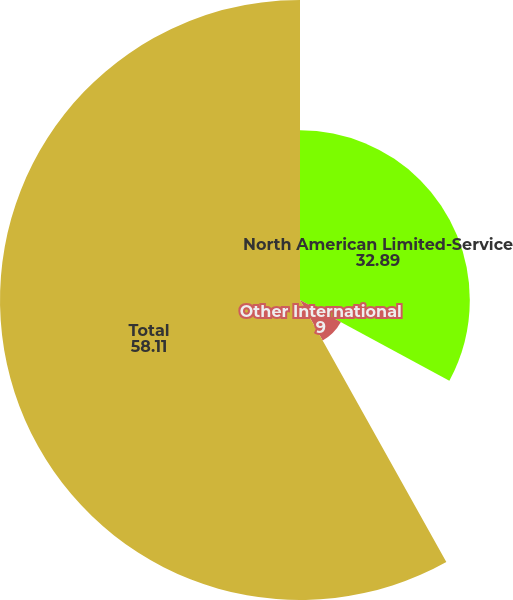<chart> <loc_0><loc_0><loc_500><loc_500><pie_chart><fcel>North American Limited-Service<fcel>Other International<fcel>Total<nl><fcel>32.89%<fcel>9.0%<fcel>58.11%<nl></chart> 